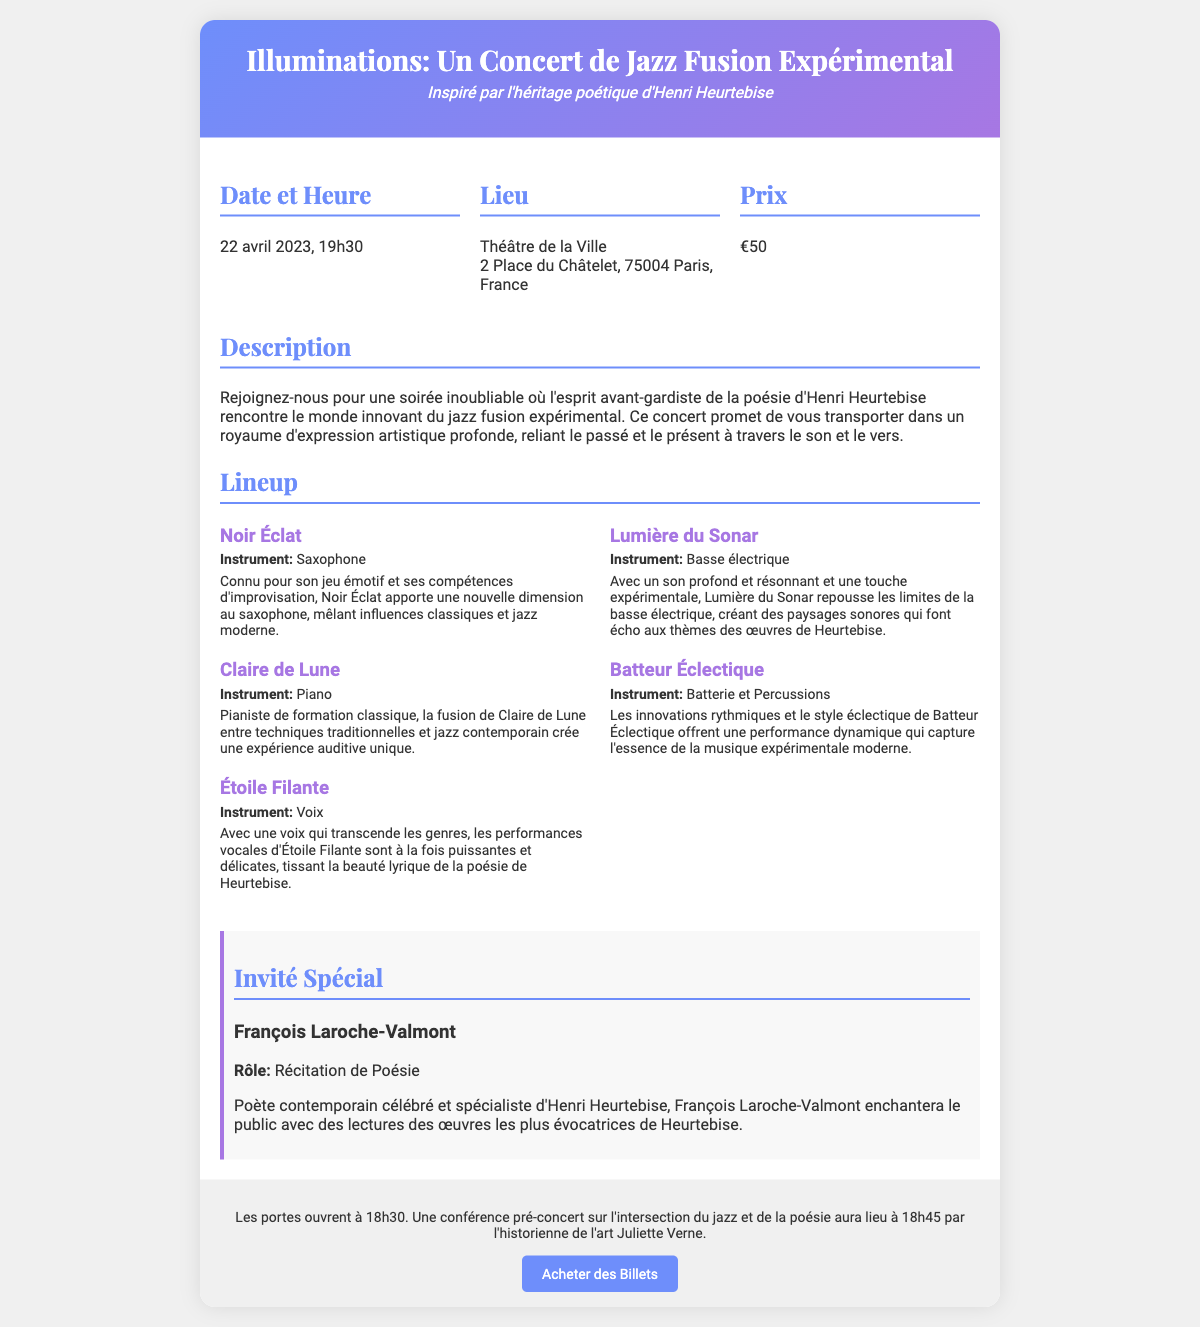Quelle est la date du concert ? La date du concert est indiquée dans la section "Date et Heure" du document.
Answer: 22 avril 2023 Quel est le prix d'un billet ? Le prix d'un billet est précisé dans la section "Prix".
Answer: €50 Qui est l'invité spécial ? L'invité spécial est mentionné dans la section "Invité Spécial".
Answer: François Laroche-Valmont Quel instrument joue Noir Éclat ? L'instrument joué par Noir Éclat est indiqué dans la crête de son nom.
Answer: Saxophone À quelle heure ouvrent les portes ? L'heure d'ouverture des portes est mentionnée dans la section "ticket footer".
Answer: 18h30 Quel lieu accueille le concert ? Le lieu est précisé dans la section "Lieu" du document.
Answer: Théâtre de la Ville Quel rôle joue François Laroche-Valmont ? Le rôle de François Laroche-Valmont est spécifié dans la section "Invité Spécial".
Answer: Récitation de Poésie Qui donne une conférence pré-concert ? La personne qui donne la conférence est mentionnée dans la section "ticket footer".
Answer: Juliette Verne Combien d'artistes figurent dans le lineup ? Le nombre d'artistes peut être compté à partir de la section "Lineup".
Answer: 5 